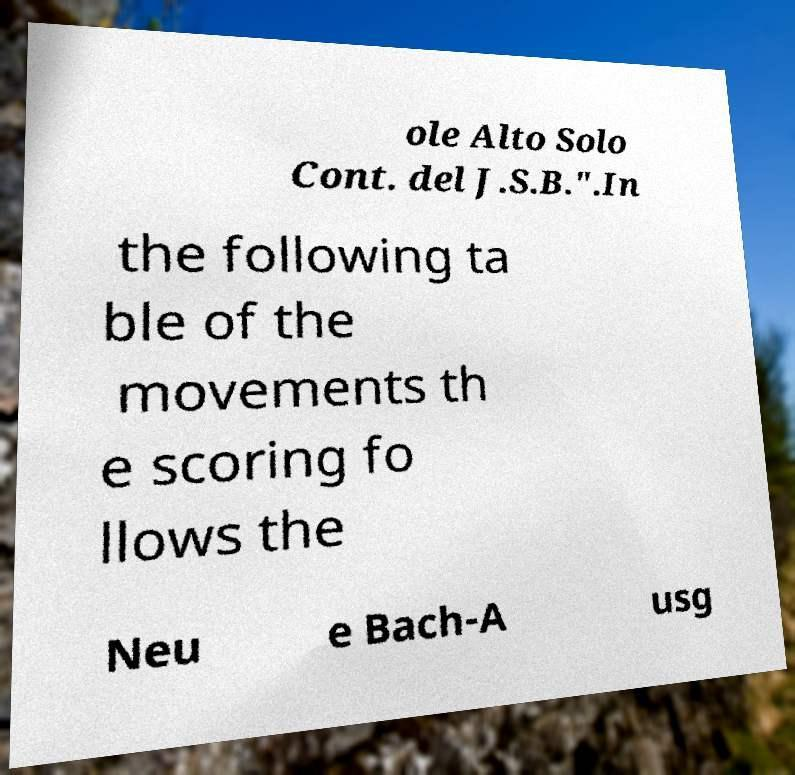Could you extract and type out the text from this image? ole Alto Solo Cont. del J.S.B.".In the following ta ble of the movements th e scoring fo llows the Neu e Bach-A usg 